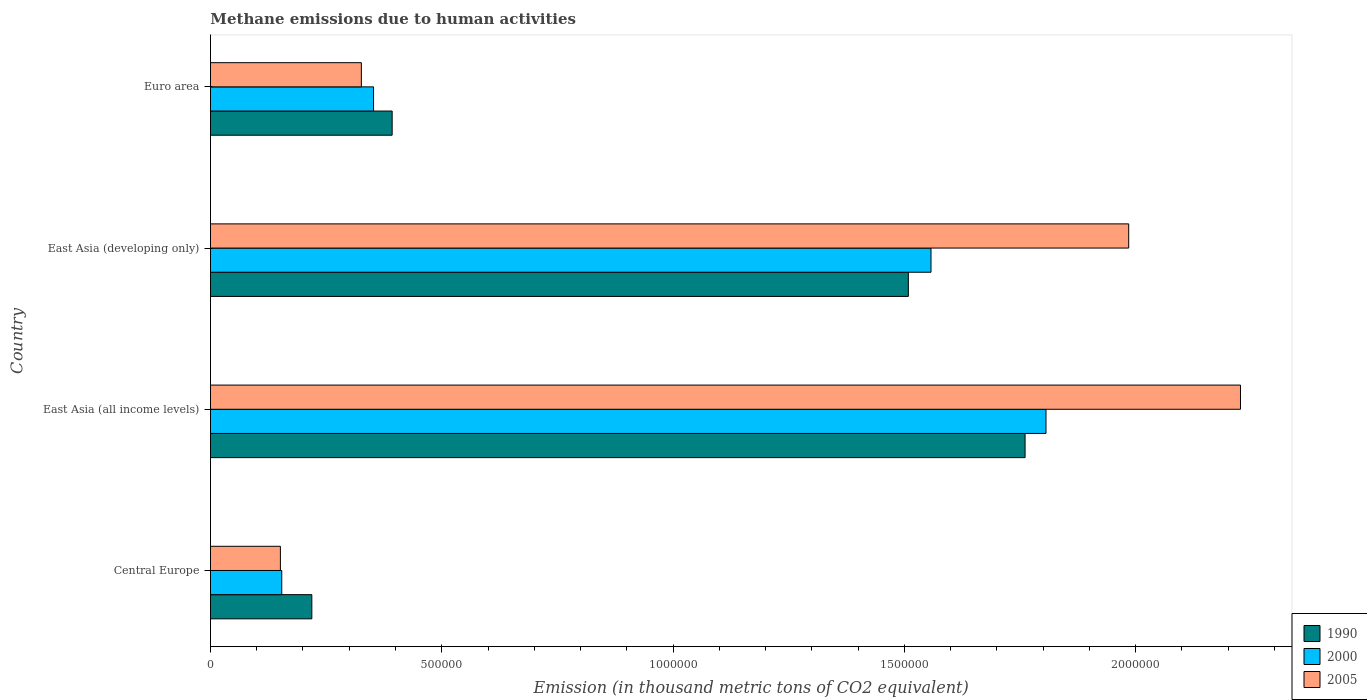Are the number of bars per tick equal to the number of legend labels?
Make the answer very short. Yes. How many bars are there on the 4th tick from the top?
Make the answer very short. 3. What is the label of the 1st group of bars from the top?
Offer a very short reply. Euro area. What is the amount of methane emitted in 2000 in Central Europe?
Offer a very short reply. 1.54e+05. Across all countries, what is the maximum amount of methane emitted in 1990?
Your response must be concise. 1.76e+06. Across all countries, what is the minimum amount of methane emitted in 1990?
Ensure brevity in your answer.  2.19e+05. In which country was the amount of methane emitted in 2000 maximum?
Your answer should be compact. East Asia (all income levels). In which country was the amount of methane emitted in 2000 minimum?
Provide a short and direct response. Central Europe. What is the total amount of methane emitted in 1990 in the graph?
Keep it short and to the point. 3.88e+06. What is the difference between the amount of methane emitted in 1990 in Central Europe and that in East Asia (developing only)?
Keep it short and to the point. -1.29e+06. What is the difference between the amount of methane emitted in 2000 in East Asia (all income levels) and the amount of methane emitted in 2005 in Central Europe?
Your answer should be compact. 1.66e+06. What is the average amount of methane emitted in 2000 per country?
Make the answer very short. 9.68e+05. What is the difference between the amount of methane emitted in 2005 and amount of methane emitted in 1990 in Euro area?
Ensure brevity in your answer.  -6.66e+04. What is the ratio of the amount of methane emitted in 2005 in East Asia (all income levels) to that in East Asia (developing only)?
Provide a short and direct response. 1.12. Is the difference between the amount of methane emitted in 2005 in Central Europe and East Asia (all income levels) greater than the difference between the amount of methane emitted in 1990 in Central Europe and East Asia (all income levels)?
Make the answer very short. No. What is the difference between the highest and the second highest amount of methane emitted in 2005?
Give a very brief answer. 2.42e+05. What is the difference between the highest and the lowest amount of methane emitted in 1990?
Offer a terse response. 1.54e+06. In how many countries, is the amount of methane emitted in 1990 greater than the average amount of methane emitted in 1990 taken over all countries?
Offer a very short reply. 2. What does the 2nd bar from the top in Central Europe represents?
Ensure brevity in your answer.  2000. What does the 1st bar from the bottom in Euro area represents?
Provide a succinct answer. 1990. How many bars are there?
Provide a succinct answer. 12. How many countries are there in the graph?
Your answer should be compact. 4. Are the values on the major ticks of X-axis written in scientific E-notation?
Keep it short and to the point. No. Does the graph contain any zero values?
Make the answer very short. No. Does the graph contain grids?
Provide a succinct answer. No. Where does the legend appear in the graph?
Offer a very short reply. Bottom right. How are the legend labels stacked?
Make the answer very short. Vertical. What is the title of the graph?
Make the answer very short. Methane emissions due to human activities. What is the label or title of the X-axis?
Offer a very short reply. Emission (in thousand metric tons of CO2 equivalent). What is the label or title of the Y-axis?
Offer a terse response. Country. What is the Emission (in thousand metric tons of CO2 equivalent) of 1990 in Central Europe?
Give a very brief answer. 2.19e+05. What is the Emission (in thousand metric tons of CO2 equivalent) of 2000 in Central Europe?
Keep it short and to the point. 1.54e+05. What is the Emission (in thousand metric tons of CO2 equivalent) in 2005 in Central Europe?
Keep it short and to the point. 1.51e+05. What is the Emission (in thousand metric tons of CO2 equivalent) of 1990 in East Asia (all income levels)?
Your answer should be very brief. 1.76e+06. What is the Emission (in thousand metric tons of CO2 equivalent) in 2000 in East Asia (all income levels)?
Keep it short and to the point. 1.81e+06. What is the Emission (in thousand metric tons of CO2 equivalent) in 2005 in East Asia (all income levels)?
Provide a succinct answer. 2.23e+06. What is the Emission (in thousand metric tons of CO2 equivalent) in 1990 in East Asia (developing only)?
Your answer should be compact. 1.51e+06. What is the Emission (in thousand metric tons of CO2 equivalent) of 2000 in East Asia (developing only)?
Provide a short and direct response. 1.56e+06. What is the Emission (in thousand metric tons of CO2 equivalent) in 2005 in East Asia (developing only)?
Make the answer very short. 1.99e+06. What is the Emission (in thousand metric tons of CO2 equivalent) of 1990 in Euro area?
Offer a terse response. 3.93e+05. What is the Emission (in thousand metric tons of CO2 equivalent) of 2000 in Euro area?
Give a very brief answer. 3.53e+05. What is the Emission (in thousand metric tons of CO2 equivalent) in 2005 in Euro area?
Your response must be concise. 3.26e+05. Across all countries, what is the maximum Emission (in thousand metric tons of CO2 equivalent) in 1990?
Provide a short and direct response. 1.76e+06. Across all countries, what is the maximum Emission (in thousand metric tons of CO2 equivalent) of 2000?
Your answer should be very brief. 1.81e+06. Across all countries, what is the maximum Emission (in thousand metric tons of CO2 equivalent) of 2005?
Offer a very short reply. 2.23e+06. Across all countries, what is the minimum Emission (in thousand metric tons of CO2 equivalent) of 1990?
Ensure brevity in your answer.  2.19e+05. Across all countries, what is the minimum Emission (in thousand metric tons of CO2 equivalent) in 2000?
Provide a short and direct response. 1.54e+05. Across all countries, what is the minimum Emission (in thousand metric tons of CO2 equivalent) of 2005?
Offer a terse response. 1.51e+05. What is the total Emission (in thousand metric tons of CO2 equivalent) in 1990 in the graph?
Make the answer very short. 3.88e+06. What is the total Emission (in thousand metric tons of CO2 equivalent) in 2000 in the graph?
Provide a succinct answer. 3.87e+06. What is the total Emission (in thousand metric tons of CO2 equivalent) of 2005 in the graph?
Make the answer very short. 4.69e+06. What is the difference between the Emission (in thousand metric tons of CO2 equivalent) in 1990 in Central Europe and that in East Asia (all income levels)?
Your answer should be very brief. -1.54e+06. What is the difference between the Emission (in thousand metric tons of CO2 equivalent) in 2000 in Central Europe and that in East Asia (all income levels)?
Provide a succinct answer. -1.65e+06. What is the difference between the Emission (in thousand metric tons of CO2 equivalent) in 2005 in Central Europe and that in East Asia (all income levels)?
Keep it short and to the point. -2.08e+06. What is the difference between the Emission (in thousand metric tons of CO2 equivalent) of 1990 in Central Europe and that in East Asia (developing only)?
Offer a terse response. -1.29e+06. What is the difference between the Emission (in thousand metric tons of CO2 equivalent) in 2000 in Central Europe and that in East Asia (developing only)?
Provide a short and direct response. -1.40e+06. What is the difference between the Emission (in thousand metric tons of CO2 equivalent) of 2005 in Central Europe and that in East Asia (developing only)?
Provide a short and direct response. -1.83e+06. What is the difference between the Emission (in thousand metric tons of CO2 equivalent) of 1990 in Central Europe and that in Euro area?
Offer a terse response. -1.74e+05. What is the difference between the Emission (in thousand metric tons of CO2 equivalent) of 2000 in Central Europe and that in Euro area?
Your answer should be compact. -1.98e+05. What is the difference between the Emission (in thousand metric tons of CO2 equivalent) of 2005 in Central Europe and that in Euro area?
Offer a terse response. -1.75e+05. What is the difference between the Emission (in thousand metric tons of CO2 equivalent) in 1990 in East Asia (all income levels) and that in East Asia (developing only)?
Your answer should be very brief. 2.52e+05. What is the difference between the Emission (in thousand metric tons of CO2 equivalent) in 2000 in East Asia (all income levels) and that in East Asia (developing only)?
Provide a succinct answer. 2.49e+05. What is the difference between the Emission (in thousand metric tons of CO2 equivalent) in 2005 in East Asia (all income levels) and that in East Asia (developing only)?
Provide a succinct answer. 2.42e+05. What is the difference between the Emission (in thousand metric tons of CO2 equivalent) of 1990 in East Asia (all income levels) and that in Euro area?
Your answer should be compact. 1.37e+06. What is the difference between the Emission (in thousand metric tons of CO2 equivalent) in 2000 in East Asia (all income levels) and that in Euro area?
Give a very brief answer. 1.45e+06. What is the difference between the Emission (in thousand metric tons of CO2 equivalent) in 2005 in East Asia (all income levels) and that in Euro area?
Your answer should be very brief. 1.90e+06. What is the difference between the Emission (in thousand metric tons of CO2 equivalent) in 1990 in East Asia (developing only) and that in Euro area?
Offer a very short reply. 1.12e+06. What is the difference between the Emission (in thousand metric tons of CO2 equivalent) in 2000 in East Asia (developing only) and that in Euro area?
Provide a short and direct response. 1.21e+06. What is the difference between the Emission (in thousand metric tons of CO2 equivalent) in 2005 in East Asia (developing only) and that in Euro area?
Offer a very short reply. 1.66e+06. What is the difference between the Emission (in thousand metric tons of CO2 equivalent) in 1990 in Central Europe and the Emission (in thousand metric tons of CO2 equivalent) in 2000 in East Asia (all income levels)?
Provide a succinct answer. -1.59e+06. What is the difference between the Emission (in thousand metric tons of CO2 equivalent) in 1990 in Central Europe and the Emission (in thousand metric tons of CO2 equivalent) in 2005 in East Asia (all income levels)?
Your answer should be compact. -2.01e+06. What is the difference between the Emission (in thousand metric tons of CO2 equivalent) in 2000 in Central Europe and the Emission (in thousand metric tons of CO2 equivalent) in 2005 in East Asia (all income levels)?
Keep it short and to the point. -2.07e+06. What is the difference between the Emission (in thousand metric tons of CO2 equivalent) in 1990 in Central Europe and the Emission (in thousand metric tons of CO2 equivalent) in 2000 in East Asia (developing only)?
Provide a short and direct response. -1.34e+06. What is the difference between the Emission (in thousand metric tons of CO2 equivalent) of 1990 in Central Europe and the Emission (in thousand metric tons of CO2 equivalent) of 2005 in East Asia (developing only)?
Give a very brief answer. -1.77e+06. What is the difference between the Emission (in thousand metric tons of CO2 equivalent) in 2000 in Central Europe and the Emission (in thousand metric tons of CO2 equivalent) in 2005 in East Asia (developing only)?
Keep it short and to the point. -1.83e+06. What is the difference between the Emission (in thousand metric tons of CO2 equivalent) in 1990 in Central Europe and the Emission (in thousand metric tons of CO2 equivalent) in 2000 in Euro area?
Your answer should be compact. -1.33e+05. What is the difference between the Emission (in thousand metric tons of CO2 equivalent) in 1990 in Central Europe and the Emission (in thousand metric tons of CO2 equivalent) in 2005 in Euro area?
Make the answer very short. -1.07e+05. What is the difference between the Emission (in thousand metric tons of CO2 equivalent) in 2000 in Central Europe and the Emission (in thousand metric tons of CO2 equivalent) in 2005 in Euro area?
Offer a terse response. -1.72e+05. What is the difference between the Emission (in thousand metric tons of CO2 equivalent) in 1990 in East Asia (all income levels) and the Emission (in thousand metric tons of CO2 equivalent) in 2000 in East Asia (developing only)?
Your answer should be compact. 2.03e+05. What is the difference between the Emission (in thousand metric tons of CO2 equivalent) in 1990 in East Asia (all income levels) and the Emission (in thousand metric tons of CO2 equivalent) in 2005 in East Asia (developing only)?
Make the answer very short. -2.24e+05. What is the difference between the Emission (in thousand metric tons of CO2 equivalent) in 2000 in East Asia (all income levels) and the Emission (in thousand metric tons of CO2 equivalent) in 2005 in East Asia (developing only)?
Give a very brief answer. -1.79e+05. What is the difference between the Emission (in thousand metric tons of CO2 equivalent) in 1990 in East Asia (all income levels) and the Emission (in thousand metric tons of CO2 equivalent) in 2000 in Euro area?
Keep it short and to the point. 1.41e+06. What is the difference between the Emission (in thousand metric tons of CO2 equivalent) in 1990 in East Asia (all income levels) and the Emission (in thousand metric tons of CO2 equivalent) in 2005 in Euro area?
Your answer should be very brief. 1.43e+06. What is the difference between the Emission (in thousand metric tons of CO2 equivalent) in 2000 in East Asia (all income levels) and the Emission (in thousand metric tons of CO2 equivalent) in 2005 in Euro area?
Provide a short and direct response. 1.48e+06. What is the difference between the Emission (in thousand metric tons of CO2 equivalent) of 1990 in East Asia (developing only) and the Emission (in thousand metric tons of CO2 equivalent) of 2000 in Euro area?
Your answer should be compact. 1.16e+06. What is the difference between the Emission (in thousand metric tons of CO2 equivalent) of 1990 in East Asia (developing only) and the Emission (in thousand metric tons of CO2 equivalent) of 2005 in Euro area?
Give a very brief answer. 1.18e+06. What is the difference between the Emission (in thousand metric tons of CO2 equivalent) of 2000 in East Asia (developing only) and the Emission (in thousand metric tons of CO2 equivalent) of 2005 in Euro area?
Keep it short and to the point. 1.23e+06. What is the average Emission (in thousand metric tons of CO2 equivalent) in 1990 per country?
Your answer should be very brief. 9.70e+05. What is the average Emission (in thousand metric tons of CO2 equivalent) of 2000 per country?
Provide a succinct answer. 9.68e+05. What is the average Emission (in thousand metric tons of CO2 equivalent) of 2005 per country?
Make the answer very short. 1.17e+06. What is the difference between the Emission (in thousand metric tons of CO2 equivalent) in 1990 and Emission (in thousand metric tons of CO2 equivalent) in 2000 in Central Europe?
Provide a succinct answer. 6.50e+04. What is the difference between the Emission (in thousand metric tons of CO2 equivalent) of 1990 and Emission (in thousand metric tons of CO2 equivalent) of 2005 in Central Europe?
Offer a very short reply. 6.80e+04. What is the difference between the Emission (in thousand metric tons of CO2 equivalent) of 2000 and Emission (in thousand metric tons of CO2 equivalent) of 2005 in Central Europe?
Provide a succinct answer. 2935.3. What is the difference between the Emission (in thousand metric tons of CO2 equivalent) in 1990 and Emission (in thousand metric tons of CO2 equivalent) in 2000 in East Asia (all income levels)?
Provide a short and direct response. -4.52e+04. What is the difference between the Emission (in thousand metric tons of CO2 equivalent) in 1990 and Emission (in thousand metric tons of CO2 equivalent) in 2005 in East Asia (all income levels)?
Your answer should be compact. -4.66e+05. What is the difference between the Emission (in thousand metric tons of CO2 equivalent) in 2000 and Emission (in thousand metric tons of CO2 equivalent) in 2005 in East Asia (all income levels)?
Offer a terse response. -4.20e+05. What is the difference between the Emission (in thousand metric tons of CO2 equivalent) in 1990 and Emission (in thousand metric tons of CO2 equivalent) in 2000 in East Asia (developing only)?
Ensure brevity in your answer.  -4.90e+04. What is the difference between the Emission (in thousand metric tons of CO2 equivalent) in 1990 and Emission (in thousand metric tons of CO2 equivalent) in 2005 in East Asia (developing only)?
Offer a terse response. -4.76e+05. What is the difference between the Emission (in thousand metric tons of CO2 equivalent) of 2000 and Emission (in thousand metric tons of CO2 equivalent) of 2005 in East Asia (developing only)?
Make the answer very short. -4.27e+05. What is the difference between the Emission (in thousand metric tons of CO2 equivalent) in 1990 and Emission (in thousand metric tons of CO2 equivalent) in 2000 in Euro area?
Your answer should be compact. 4.02e+04. What is the difference between the Emission (in thousand metric tons of CO2 equivalent) in 1990 and Emission (in thousand metric tons of CO2 equivalent) in 2005 in Euro area?
Offer a very short reply. 6.66e+04. What is the difference between the Emission (in thousand metric tons of CO2 equivalent) in 2000 and Emission (in thousand metric tons of CO2 equivalent) in 2005 in Euro area?
Your answer should be compact. 2.63e+04. What is the ratio of the Emission (in thousand metric tons of CO2 equivalent) of 1990 in Central Europe to that in East Asia (all income levels)?
Make the answer very short. 0.12. What is the ratio of the Emission (in thousand metric tons of CO2 equivalent) of 2000 in Central Europe to that in East Asia (all income levels)?
Keep it short and to the point. 0.09. What is the ratio of the Emission (in thousand metric tons of CO2 equivalent) of 2005 in Central Europe to that in East Asia (all income levels)?
Your response must be concise. 0.07. What is the ratio of the Emission (in thousand metric tons of CO2 equivalent) in 1990 in Central Europe to that in East Asia (developing only)?
Offer a very short reply. 0.15. What is the ratio of the Emission (in thousand metric tons of CO2 equivalent) in 2000 in Central Europe to that in East Asia (developing only)?
Offer a very short reply. 0.1. What is the ratio of the Emission (in thousand metric tons of CO2 equivalent) in 2005 in Central Europe to that in East Asia (developing only)?
Offer a terse response. 0.08. What is the ratio of the Emission (in thousand metric tons of CO2 equivalent) of 1990 in Central Europe to that in Euro area?
Offer a very short reply. 0.56. What is the ratio of the Emission (in thousand metric tons of CO2 equivalent) in 2000 in Central Europe to that in Euro area?
Your answer should be very brief. 0.44. What is the ratio of the Emission (in thousand metric tons of CO2 equivalent) of 2005 in Central Europe to that in Euro area?
Ensure brevity in your answer.  0.46. What is the ratio of the Emission (in thousand metric tons of CO2 equivalent) of 1990 in East Asia (all income levels) to that in East Asia (developing only)?
Give a very brief answer. 1.17. What is the ratio of the Emission (in thousand metric tons of CO2 equivalent) of 2000 in East Asia (all income levels) to that in East Asia (developing only)?
Ensure brevity in your answer.  1.16. What is the ratio of the Emission (in thousand metric tons of CO2 equivalent) in 2005 in East Asia (all income levels) to that in East Asia (developing only)?
Keep it short and to the point. 1.12. What is the ratio of the Emission (in thousand metric tons of CO2 equivalent) in 1990 in East Asia (all income levels) to that in Euro area?
Provide a short and direct response. 4.48. What is the ratio of the Emission (in thousand metric tons of CO2 equivalent) of 2000 in East Asia (all income levels) to that in Euro area?
Ensure brevity in your answer.  5.12. What is the ratio of the Emission (in thousand metric tons of CO2 equivalent) in 2005 in East Asia (all income levels) to that in Euro area?
Offer a very short reply. 6.83. What is the ratio of the Emission (in thousand metric tons of CO2 equivalent) of 1990 in East Asia (developing only) to that in Euro area?
Provide a short and direct response. 3.84. What is the ratio of the Emission (in thousand metric tons of CO2 equivalent) in 2000 in East Asia (developing only) to that in Euro area?
Offer a terse response. 4.42. What is the ratio of the Emission (in thousand metric tons of CO2 equivalent) of 2005 in East Asia (developing only) to that in Euro area?
Ensure brevity in your answer.  6.09. What is the difference between the highest and the second highest Emission (in thousand metric tons of CO2 equivalent) of 1990?
Offer a very short reply. 2.52e+05. What is the difference between the highest and the second highest Emission (in thousand metric tons of CO2 equivalent) in 2000?
Your response must be concise. 2.49e+05. What is the difference between the highest and the second highest Emission (in thousand metric tons of CO2 equivalent) in 2005?
Keep it short and to the point. 2.42e+05. What is the difference between the highest and the lowest Emission (in thousand metric tons of CO2 equivalent) of 1990?
Provide a succinct answer. 1.54e+06. What is the difference between the highest and the lowest Emission (in thousand metric tons of CO2 equivalent) of 2000?
Offer a terse response. 1.65e+06. What is the difference between the highest and the lowest Emission (in thousand metric tons of CO2 equivalent) in 2005?
Offer a terse response. 2.08e+06. 